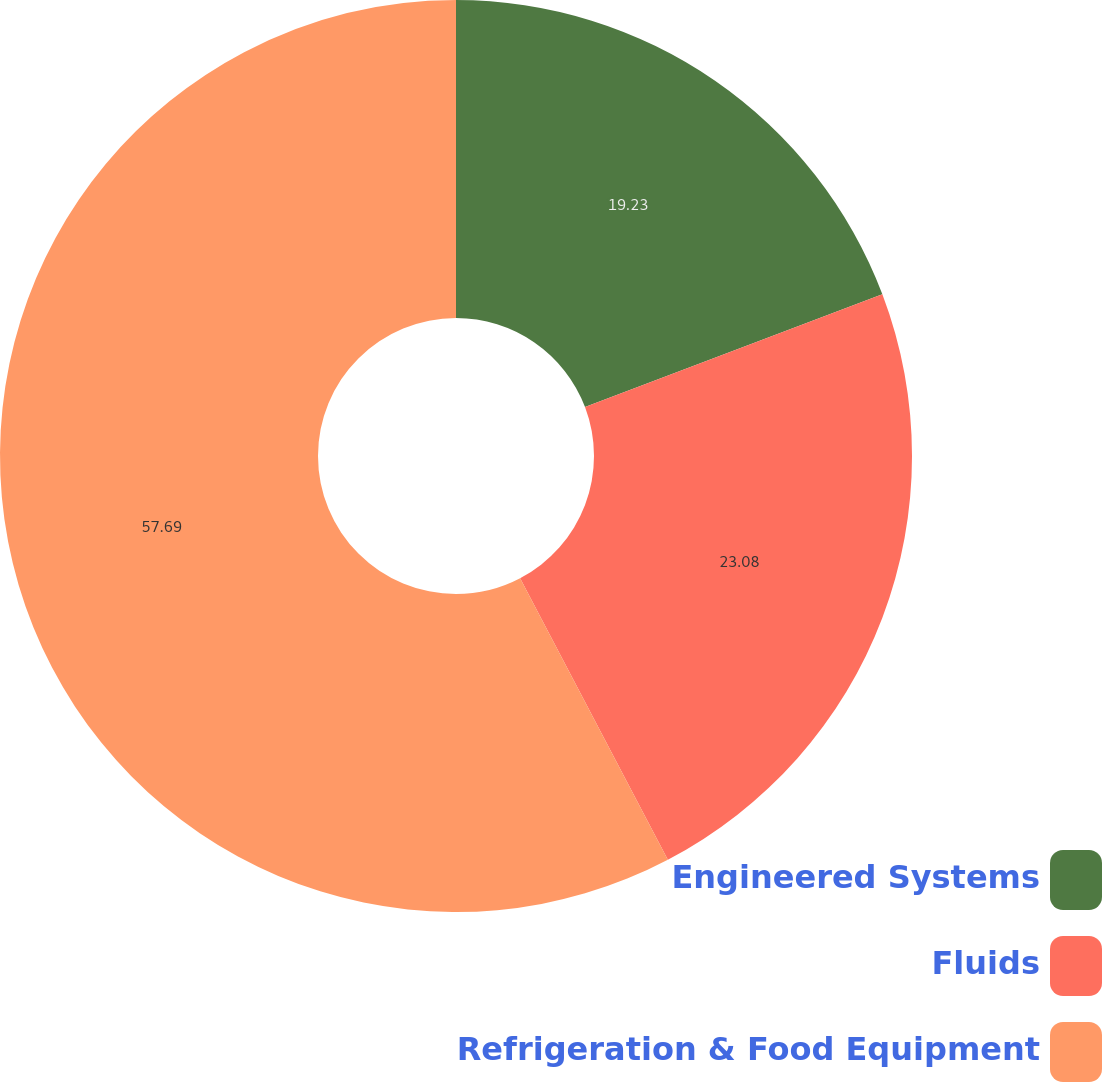Convert chart. <chart><loc_0><loc_0><loc_500><loc_500><pie_chart><fcel>Engineered Systems<fcel>Fluids<fcel>Refrigeration & Food Equipment<nl><fcel>19.23%<fcel>23.08%<fcel>57.69%<nl></chart> 